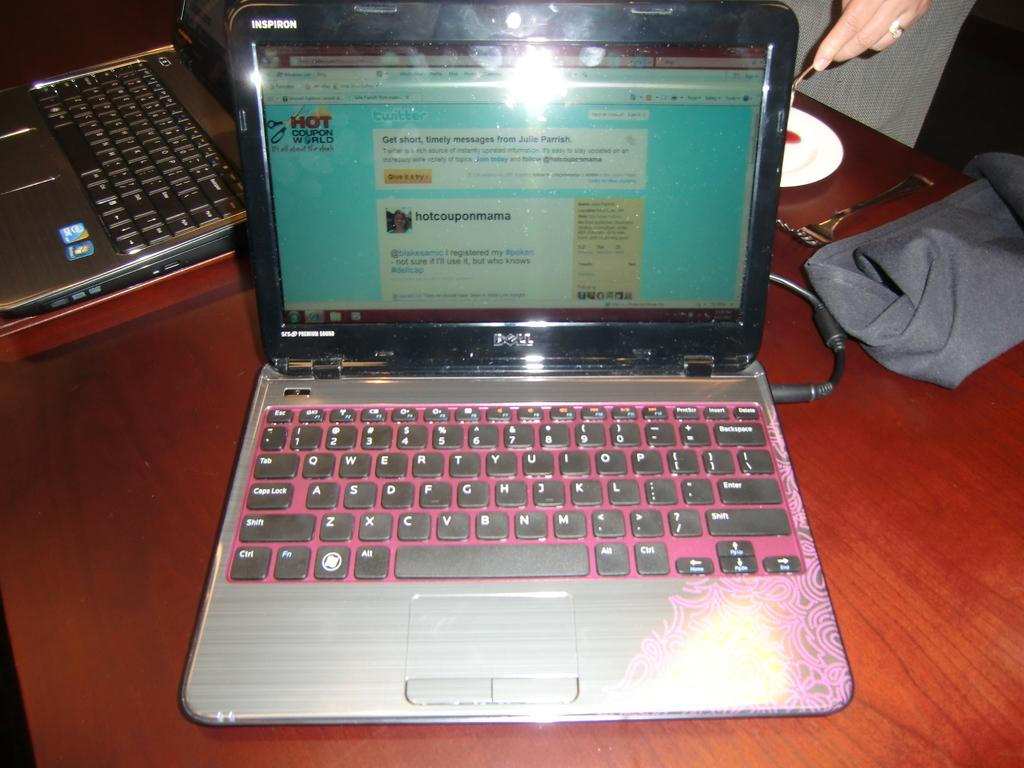<image>
Summarize the visual content of the image. a lap top open to a webpage with Hot something on it, it's not readable.. 